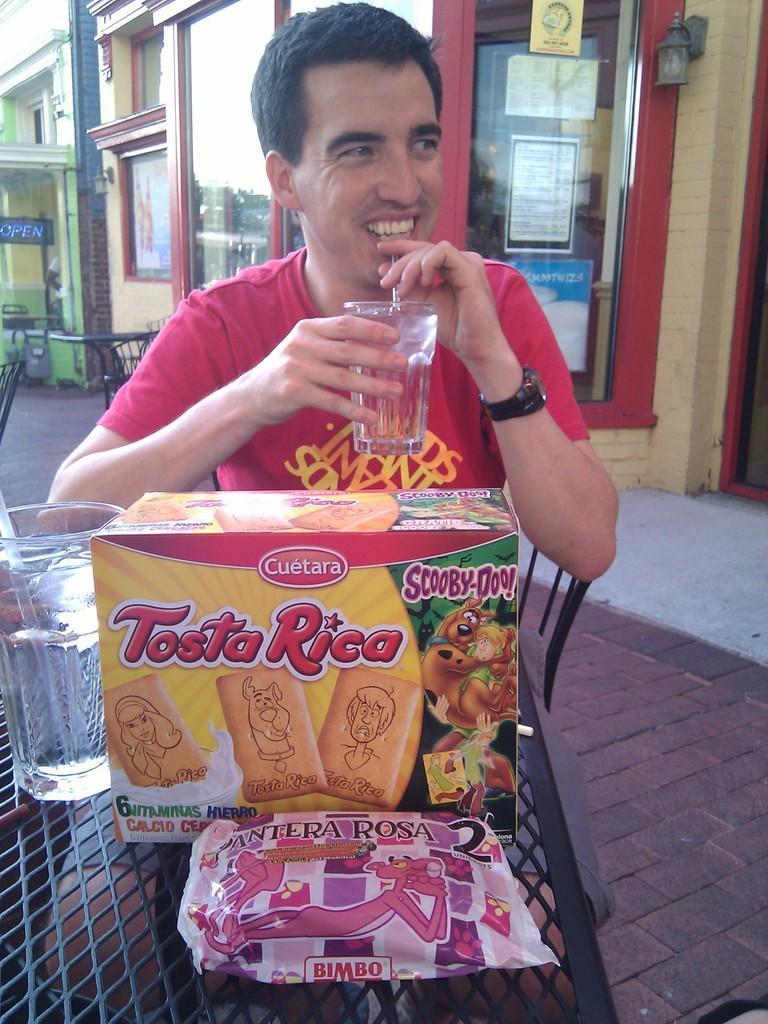Could you give a brief overview of what you see in this image? In this image I can see a person is sitting on the chair in front of the table on which there is a glass, box and a cover. In the background I can see a building, boards and a table. This image is taken may be in a open restaurant. 